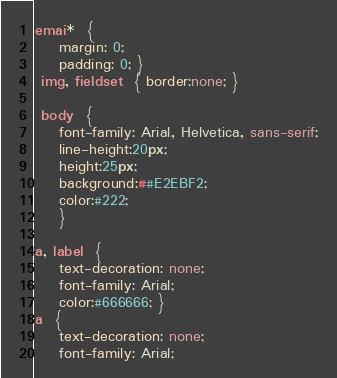Convert code to text. <code><loc_0><loc_0><loc_500><loc_500><_CSS_>emai*  {
	margin: 0;
	padding: 0; }
 img, fieldset  { border:none; }
 
 body  {
    font-family: Arial, Helvetica, sans-serif;
	line-height:20px;
	height:25px;
	background:##E2EBF2;
	color:#222;
	}
 
a, label  {
	text-decoration: none;
	font-family: Arial;
	color:#666666; }
a  {
	text-decoration: none;
	font-family: Arial;</code> 